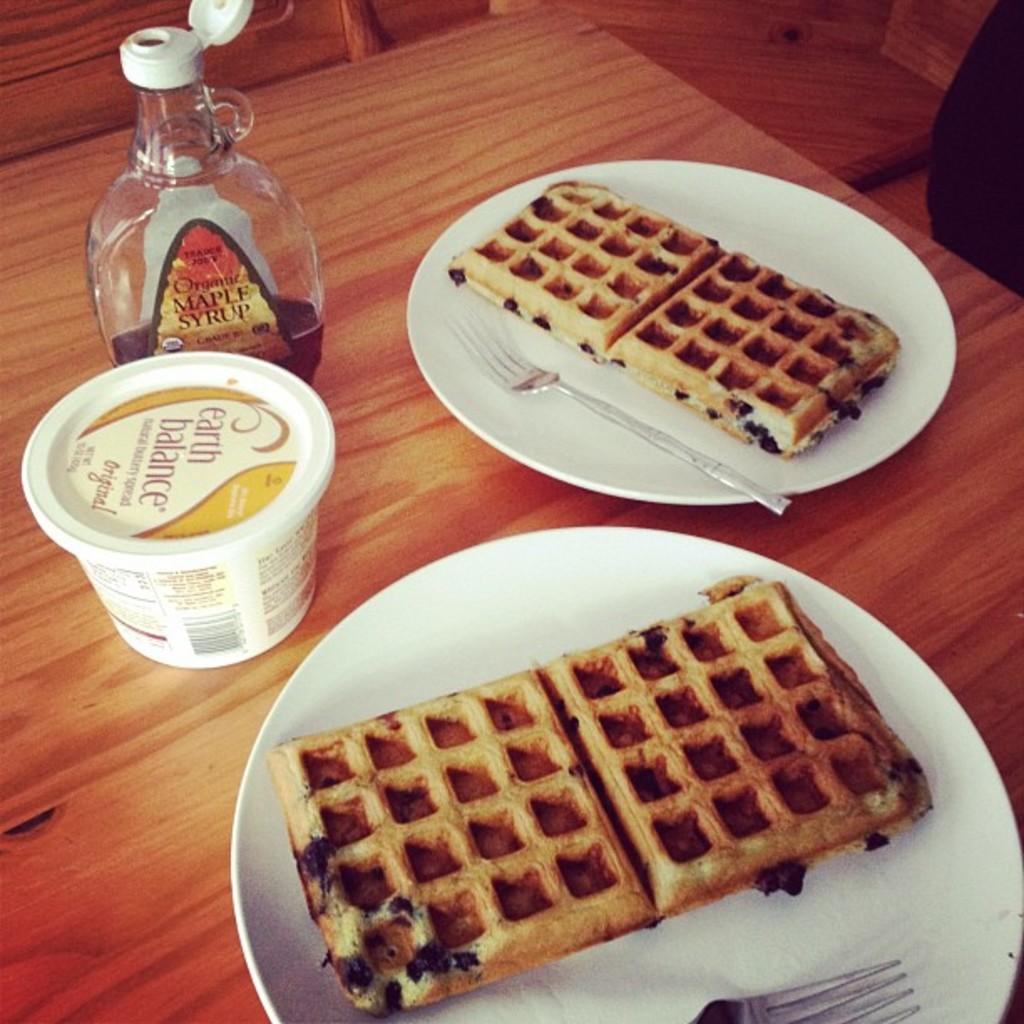What is on the plate that is visible in the image? There is food on the plate in the image. What utensil is visible in the image? There is a fork in the image. What else can be seen on the table in the image? There is a bottle and a box on the table in the image. How does the fork connect to the truck in the image? There is no truck present in the image, and therefore no connection between the fork and a truck can be observed. 